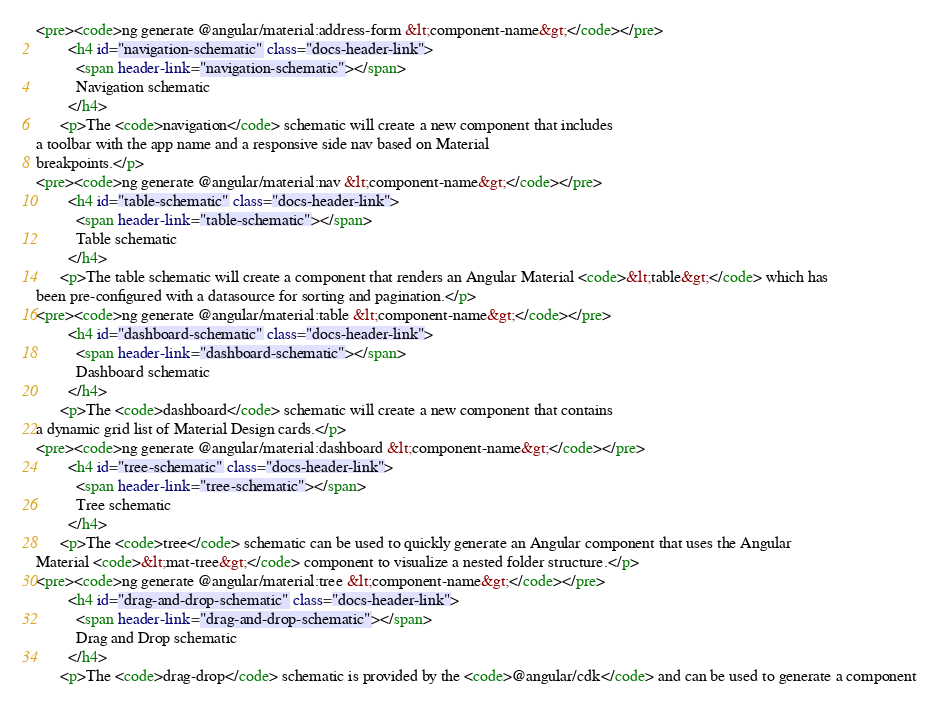Convert code to text. <code><loc_0><loc_0><loc_500><loc_500><_HTML_><pre><code>ng generate @angular/material:address-form &lt;component-name&gt;</code></pre>
        <h4 id="navigation-schematic" class="docs-header-link">
          <span header-link="navigation-schematic"></span>
          Navigation schematic
        </h4>
      <p>The <code>navigation</code> schematic will create a new component that includes
a toolbar with the app name and a responsive side nav based on Material
breakpoints.</p>
<pre><code>ng generate @angular/material:nav &lt;component-name&gt;</code></pre>
        <h4 id="table-schematic" class="docs-header-link">
          <span header-link="table-schematic"></span>
          Table schematic
        </h4>
      <p>The table schematic will create a component that renders an Angular Material <code>&lt;table&gt;</code> which has
been pre-configured with a datasource for sorting and pagination.</p>
<pre><code>ng generate @angular/material:table &lt;component-name&gt;</code></pre>
        <h4 id="dashboard-schematic" class="docs-header-link">
          <span header-link="dashboard-schematic"></span>
          Dashboard schematic
        </h4>
      <p>The <code>dashboard</code> schematic will create a new component that contains
a dynamic grid list of Material Design cards.</p>
<pre><code>ng generate @angular/material:dashboard &lt;component-name&gt;</code></pre>
        <h4 id="tree-schematic" class="docs-header-link">
          <span header-link="tree-schematic"></span>
          Tree schematic
        </h4>
      <p>The <code>tree</code> schematic can be used to quickly generate an Angular component that uses the Angular
Material <code>&lt;mat-tree&gt;</code> component to visualize a nested folder structure.</p>
<pre><code>ng generate @angular/material:tree &lt;component-name&gt;</code></pre>
        <h4 id="drag-and-drop-schematic" class="docs-header-link">
          <span header-link="drag-and-drop-schematic"></span>
          Drag and Drop schematic
        </h4>
      <p>The <code>drag-drop</code> schematic is provided by the <code>@angular/cdk</code> and can be used to generate a component</code> 